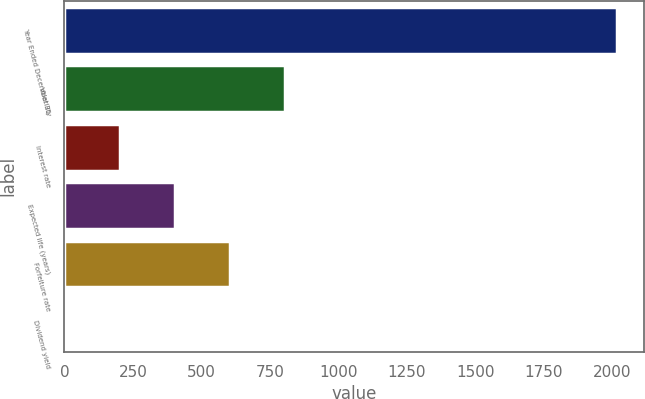<chart> <loc_0><loc_0><loc_500><loc_500><bar_chart><fcel>Year Ended December 31<fcel>Volatility<fcel>Interest rate<fcel>Expected life (years)<fcel>Forfeiture rate<fcel>Dividend yield<nl><fcel>2017<fcel>807.04<fcel>202.06<fcel>403.72<fcel>605.38<fcel>0.4<nl></chart> 